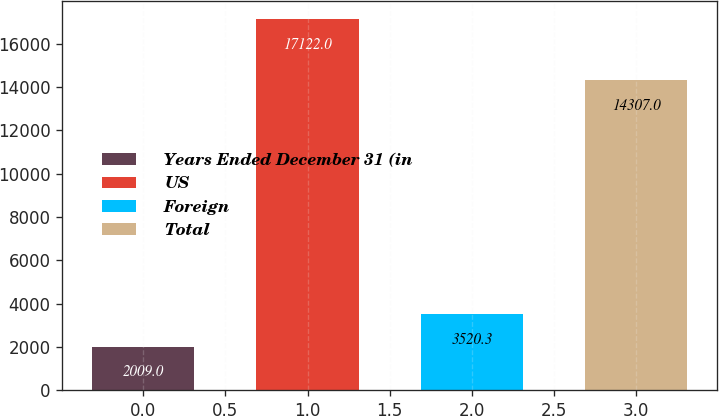Convert chart to OTSL. <chart><loc_0><loc_0><loc_500><loc_500><bar_chart><fcel>Years Ended December 31 (in<fcel>US<fcel>Foreign<fcel>Total<nl><fcel>2009<fcel>17122<fcel>3520.3<fcel>14307<nl></chart> 